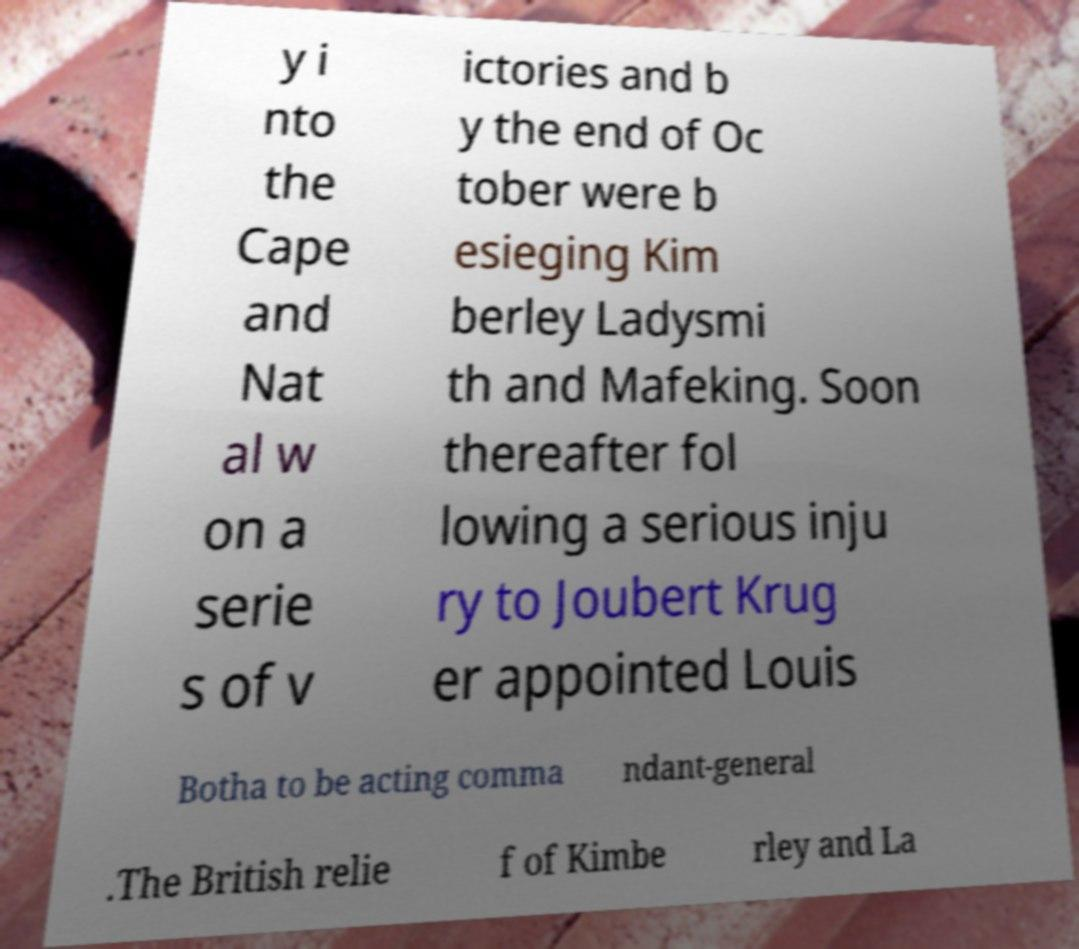Please read and relay the text visible in this image. What does it say? y i nto the Cape and Nat al w on a serie s of v ictories and b y the end of Oc tober were b esieging Kim berley Ladysmi th and Mafeking. Soon thereafter fol lowing a serious inju ry to Joubert Krug er appointed Louis Botha to be acting comma ndant-general .The British relie f of Kimbe rley and La 